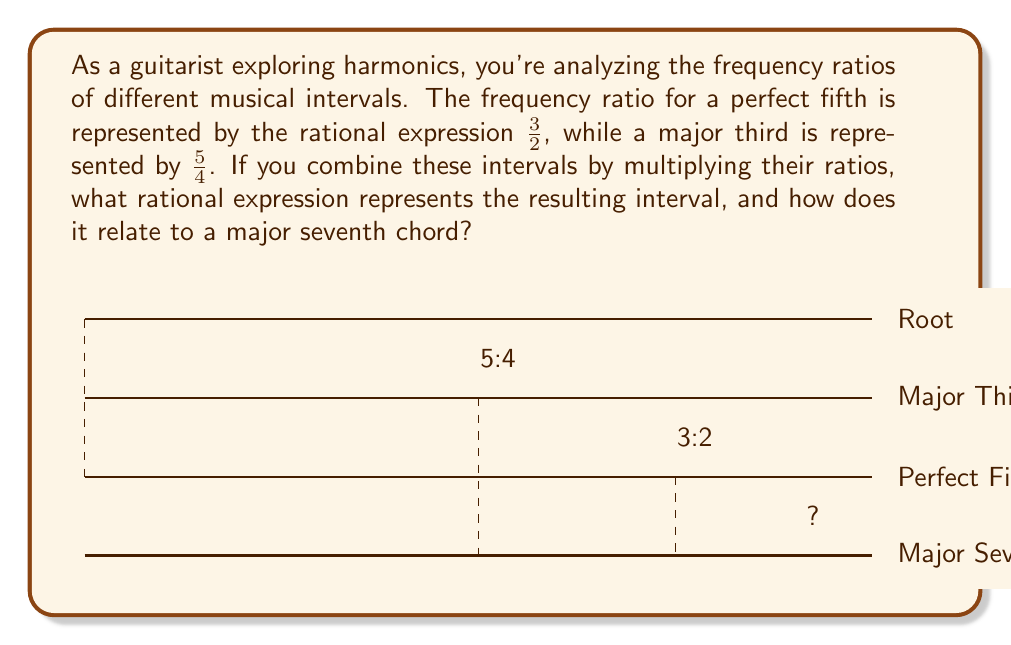Provide a solution to this math problem. Let's approach this step-by-step:

1) We start with two rational expressions:
   - Perfect fifth: $\frac{3}{2}$
   - Major third: $\frac{5}{4}$

2) To combine these intervals, we multiply their ratios:

   $$\frac{3}{2} \cdot \frac{5}{4} = \frac{3 \cdot 5}{2 \cdot 4} = \frac{15}{8}$$

3) This simplification is done by multiplying the numerators and denominators separately.

4) The resulting rational expression $\frac{15}{8}$ represents the interval created by stacking a perfect fifth and a major third.

5) In music theory, this interval is known as a major seventh, which is a key component of a major seventh chord.

6) To verify, we can break down the major seventh ratio:
   
   $$\frac{15}{8} = \frac{15}{16} \cdot 2 = 1.875$$

   This is indeed the frequency ratio for a major seventh (about 11 semitones).

7) A major seventh chord consists of a root, major third, perfect fifth, and major seventh. The rational expression we derived ($\frac{15}{8}$) represents the relationship between the root and the major seventh in this chord structure.
Answer: $\frac{15}{8}$, representing a major seventh interval 